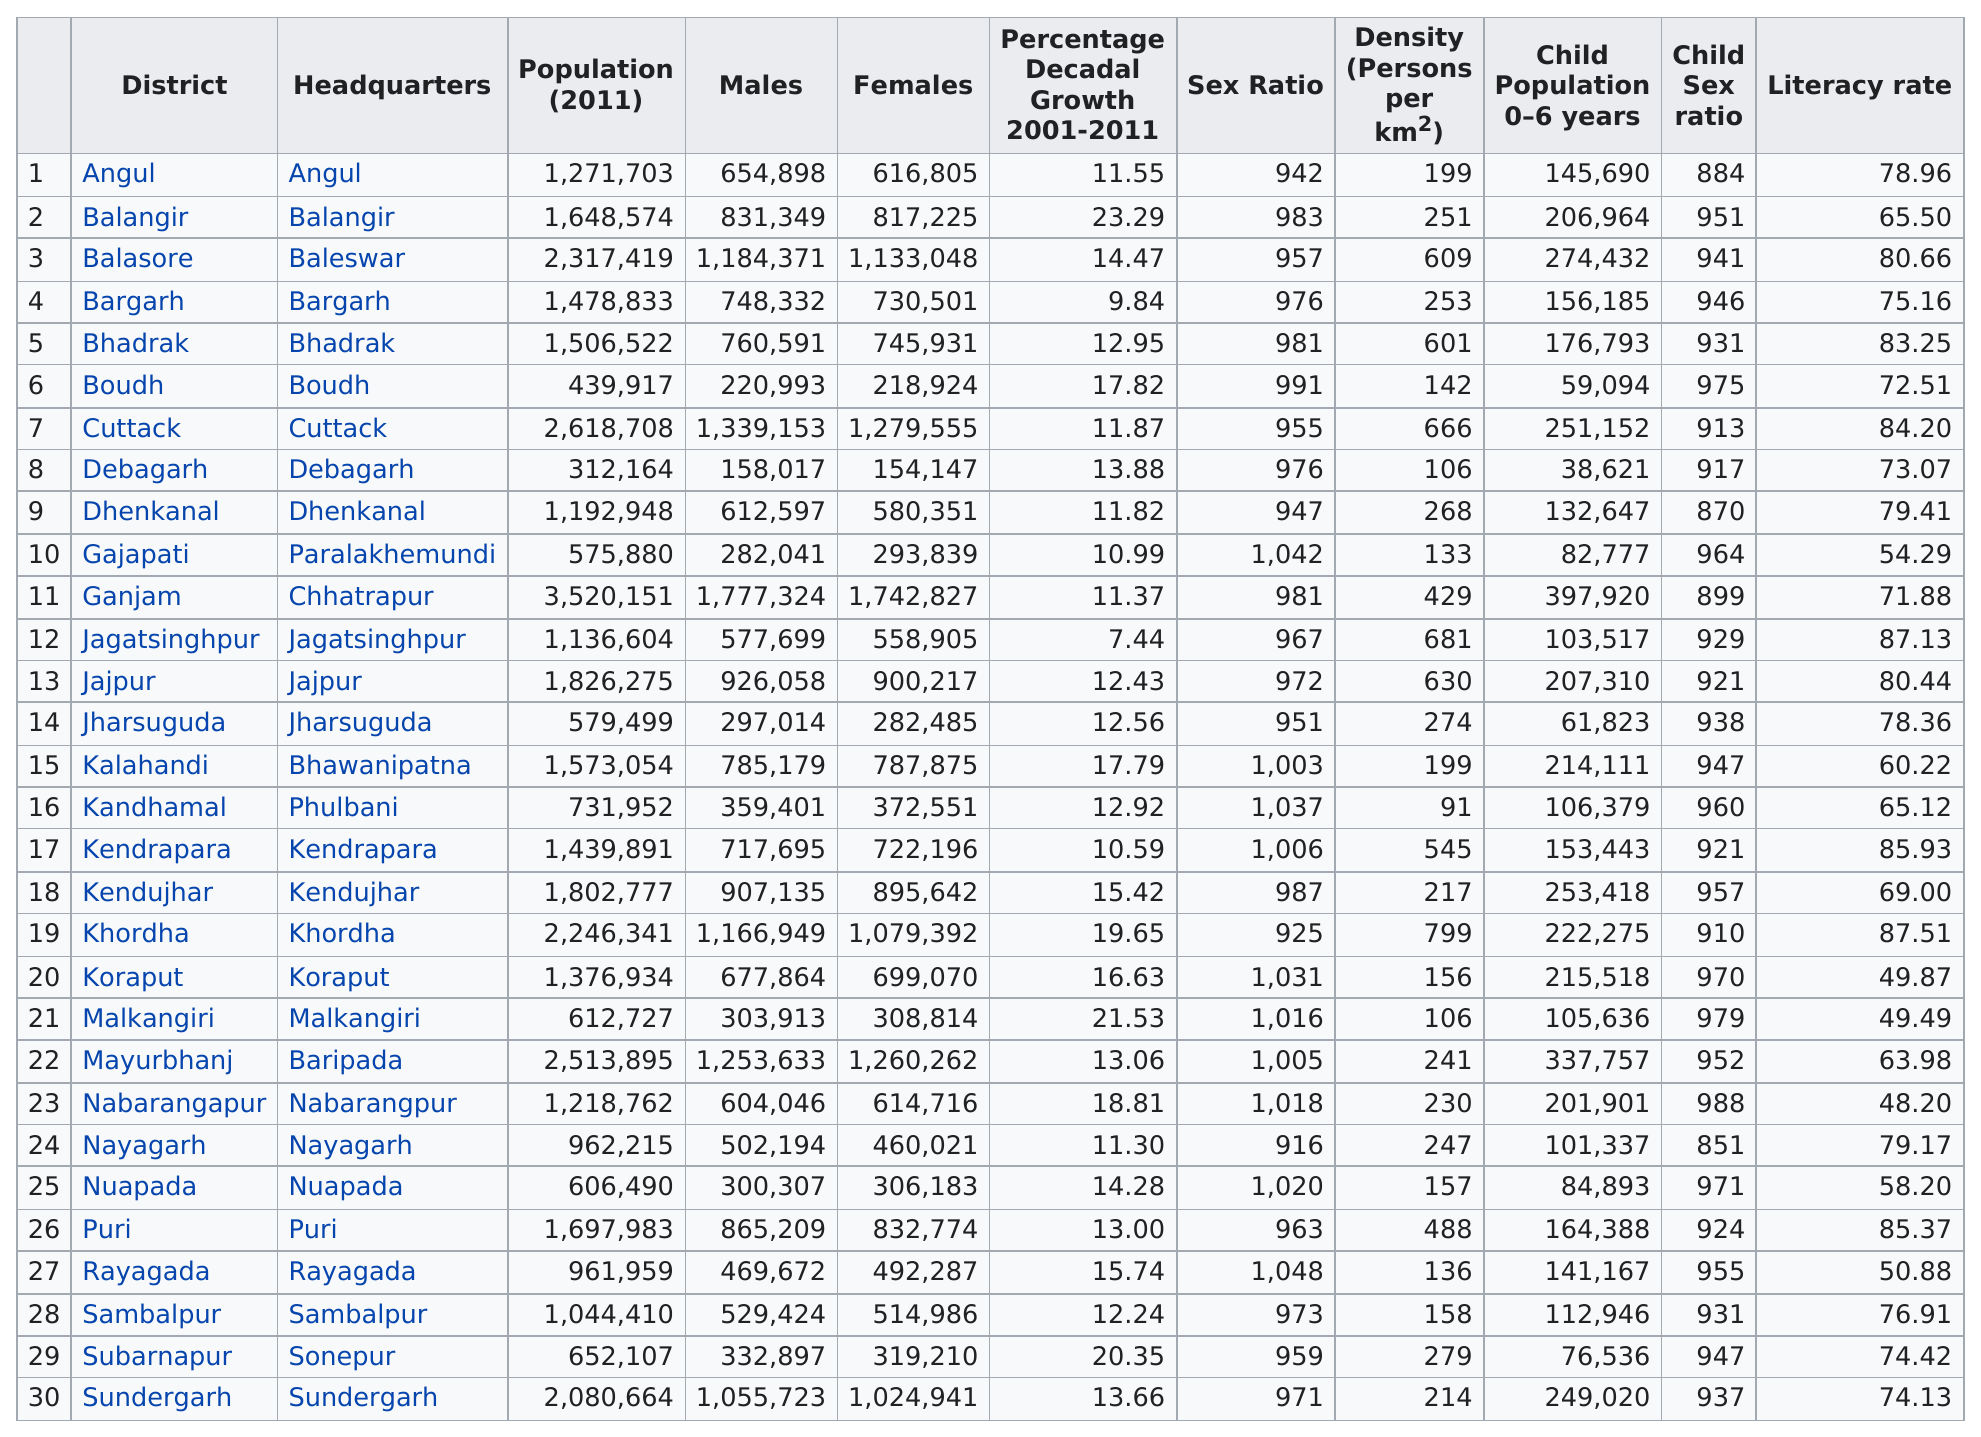Mention a couple of crucial points in this snapshot. Cuttack has a higher population than Angul. The difference in the child population between Koraput and Puri is 51,130. The district of Jagatsinghpur had the least population growth from 2001 to 2011. Based on the data provided, there were 10 districts with a decadal growth above 15%. Khordha district had the highest concentration of people per km, according to the data. 